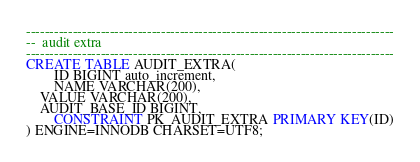<code> <loc_0><loc_0><loc_500><loc_500><_SQL_>

-------------------------------------------------------------------------------
--  audit extra
-------------------------------------------------------------------------------
CREATE TABLE AUDIT_EXTRA(
        ID BIGINT auto_increment,
        NAME VARCHAR(200),
	VALUE VARCHAR(200),
	AUDIT_BASE_ID BIGINT,
        CONSTRAINT PK_AUDIT_EXTRA PRIMARY KEY(ID)
) ENGINE=INNODB CHARSET=UTF8;

</code> 